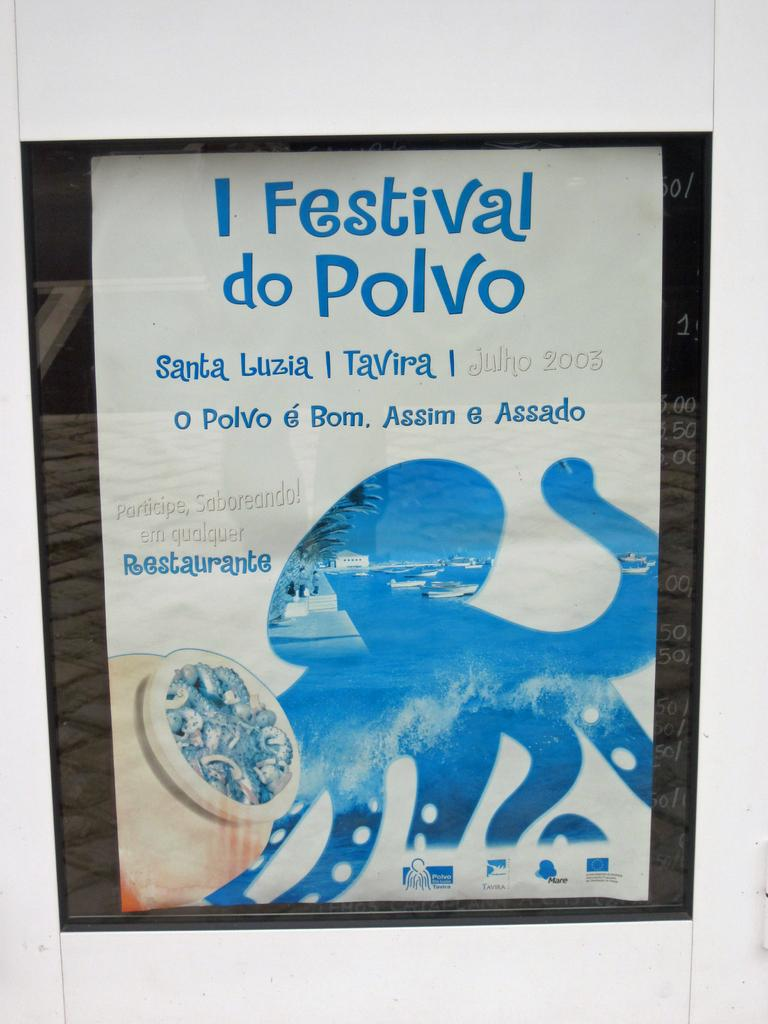Provide a one-sentence caption for the provided image. A book titled I Festival do Polvo with the outline of an octupus on it. 